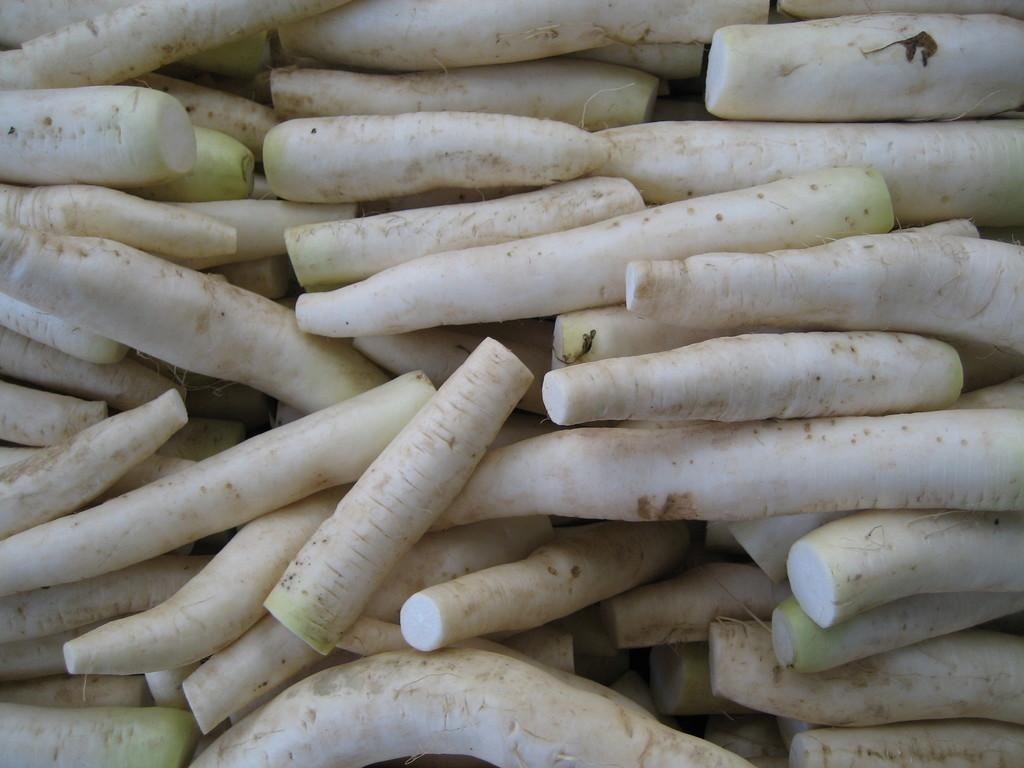What type of vegetables are present in the image? There are radishes in the image. How are the radishes arranged in the image? The radishes are arranged one beside the other. What type of engine is powering the radishes in the image? There is no engine present in the image, as the radishes are vegetables and not machines. 